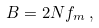Convert formula to latex. <formula><loc_0><loc_0><loc_500><loc_500>B = 2 N f _ { m } \, ,</formula> 